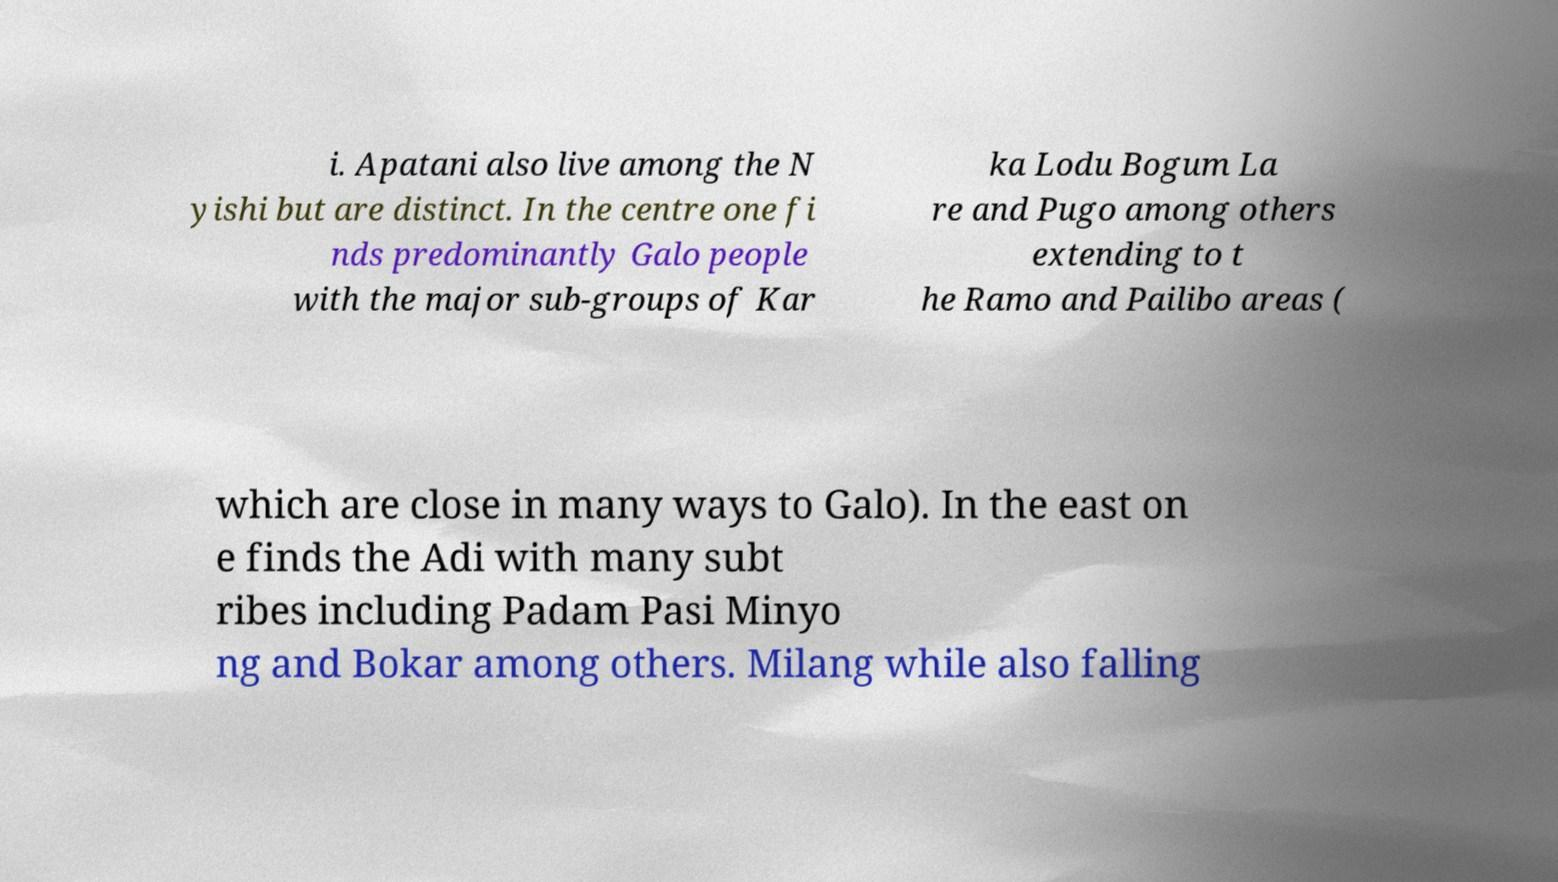Can you read and provide the text displayed in the image?This photo seems to have some interesting text. Can you extract and type it out for me? i. Apatani also live among the N yishi but are distinct. In the centre one fi nds predominantly Galo people with the major sub-groups of Kar ka Lodu Bogum La re and Pugo among others extending to t he Ramo and Pailibo areas ( which are close in many ways to Galo). In the east on e finds the Adi with many subt ribes including Padam Pasi Minyo ng and Bokar among others. Milang while also falling 